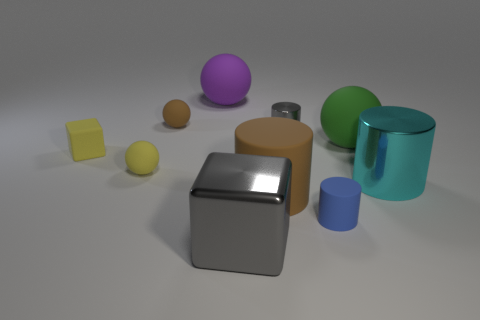What is the material of the gray cube that is the same size as the cyan cylinder?
Provide a succinct answer. Metal. Are there more small purple blocks than purple balls?
Ensure brevity in your answer.  No. How many other things are the same color as the big shiny cylinder?
Offer a terse response. 0. What number of things are left of the large cyan thing and behind the tiny matte cylinder?
Provide a succinct answer. 7. Are there more objects on the right side of the small brown rubber ball than blue cylinders that are to the left of the tiny gray shiny thing?
Your answer should be very brief. Yes. There is a gray object to the right of the big gray metal block; what is it made of?
Offer a very short reply. Metal. Is the shape of the cyan shiny thing the same as the gray object in front of the cyan cylinder?
Provide a succinct answer. No. There is a sphere that is to the right of the small matte object on the right side of the big purple object; what number of small blue things are on the right side of it?
Give a very brief answer. 0. What color is the other rubber object that is the same shape as the blue rubber object?
Offer a very short reply. Brown. How many balls are either yellow matte things or purple things?
Offer a terse response. 2. 